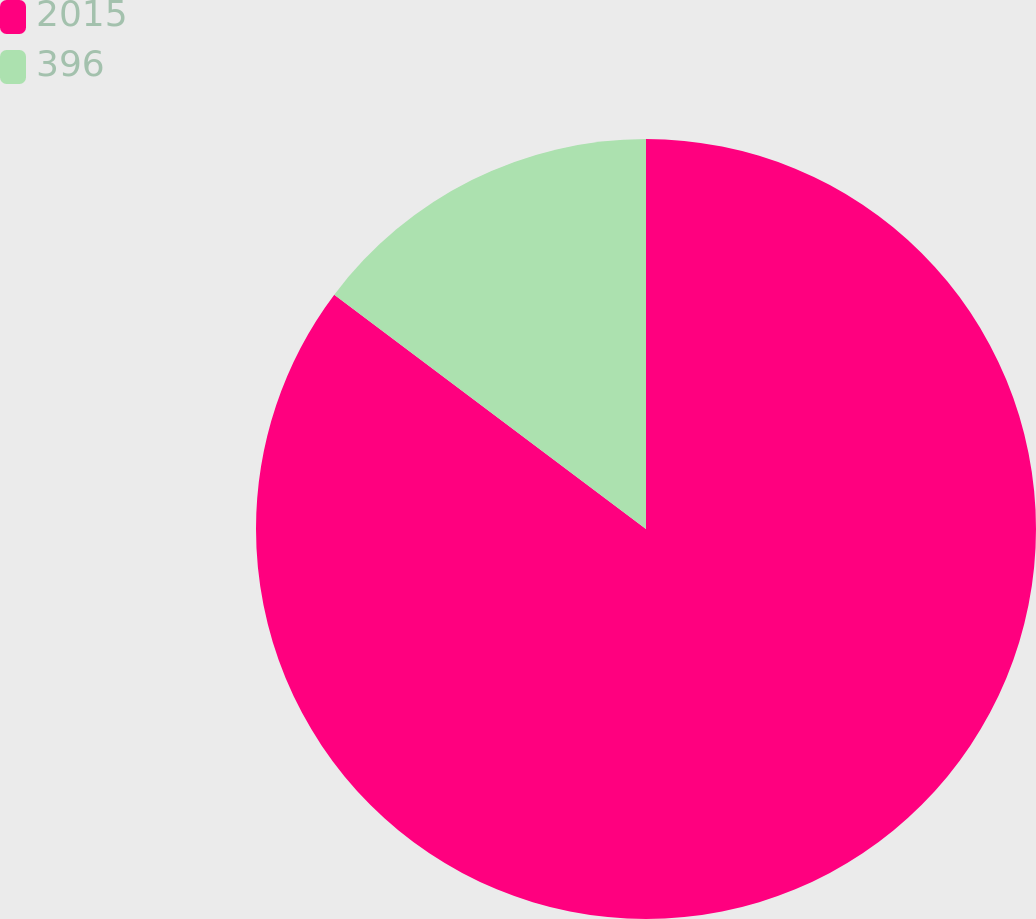Convert chart. <chart><loc_0><loc_0><loc_500><loc_500><pie_chart><fcel>2015<fcel>396<nl><fcel>85.26%<fcel>14.74%<nl></chart> 